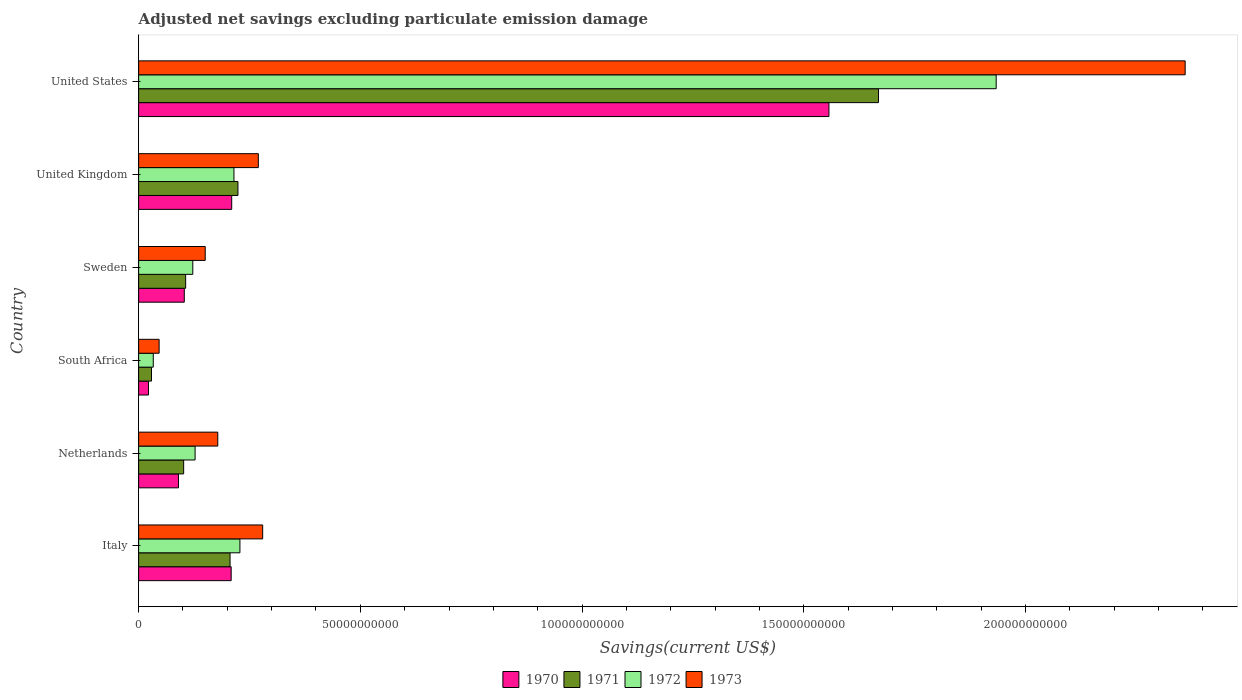How many different coloured bars are there?
Offer a very short reply. 4. How many groups of bars are there?
Your answer should be compact. 6. Are the number of bars on each tick of the Y-axis equal?
Ensure brevity in your answer.  Yes. How many bars are there on the 2nd tick from the bottom?
Offer a terse response. 4. In how many cases, is the number of bars for a given country not equal to the number of legend labels?
Offer a terse response. 0. What is the adjusted net savings in 1972 in Netherlands?
Keep it short and to the point. 1.27e+1. Across all countries, what is the maximum adjusted net savings in 1972?
Your response must be concise. 1.93e+11. Across all countries, what is the minimum adjusted net savings in 1973?
Give a very brief answer. 4.62e+09. In which country was the adjusted net savings in 1973 minimum?
Provide a succinct answer. South Africa. What is the total adjusted net savings in 1971 in the graph?
Offer a very short reply. 2.34e+11. What is the difference between the adjusted net savings in 1972 in Italy and that in Netherlands?
Keep it short and to the point. 1.01e+1. What is the difference between the adjusted net savings in 1973 in United Kingdom and the adjusted net savings in 1972 in Netherlands?
Give a very brief answer. 1.43e+1. What is the average adjusted net savings in 1971 per country?
Offer a terse response. 3.89e+1. What is the difference between the adjusted net savings in 1971 and adjusted net savings in 1973 in South Africa?
Provide a succinct answer. -1.72e+09. What is the ratio of the adjusted net savings in 1970 in Sweden to that in United Kingdom?
Keep it short and to the point. 0.49. What is the difference between the highest and the second highest adjusted net savings in 1972?
Provide a succinct answer. 1.71e+11. What is the difference between the highest and the lowest adjusted net savings in 1970?
Offer a terse response. 1.53e+11. In how many countries, is the adjusted net savings in 1971 greater than the average adjusted net savings in 1971 taken over all countries?
Your answer should be very brief. 1. Is the sum of the adjusted net savings in 1973 in South Africa and United Kingdom greater than the maximum adjusted net savings in 1970 across all countries?
Make the answer very short. No. How many countries are there in the graph?
Provide a succinct answer. 6. What is the difference between two consecutive major ticks on the X-axis?
Ensure brevity in your answer.  5.00e+1. Does the graph contain any zero values?
Provide a succinct answer. No. Where does the legend appear in the graph?
Your answer should be very brief. Bottom center. How many legend labels are there?
Offer a very short reply. 4. How are the legend labels stacked?
Keep it short and to the point. Horizontal. What is the title of the graph?
Offer a terse response. Adjusted net savings excluding particulate emission damage. What is the label or title of the X-axis?
Your answer should be very brief. Savings(current US$). What is the Savings(current US$) of 1970 in Italy?
Offer a very short reply. 2.09e+1. What is the Savings(current US$) in 1971 in Italy?
Give a very brief answer. 2.06e+1. What is the Savings(current US$) in 1972 in Italy?
Your response must be concise. 2.28e+1. What is the Savings(current US$) of 1973 in Italy?
Give a very brief answer. 2.80e+1. What is the Savings(current US$) of 1970 in Netherlands?
Offer a terse response. 8.99e+09. What is the Savings(current US$) of 1971 in Netherlands?
Offer a terse response. 1.02e+1. What is the Savings(current US$) in 1972 in Netherlands?
Provide a short and direct response. 1.27e+1. What is the Savings(current US$) of 1973 in Netherlands?
Your answer should be compact. 1.79e+1. What is the Savings(current US$) in 1970 in South Africa?
Provide a succinct answer. 2.22e+09. What is the Savings(current US$) of 1971 in South Africa?
Your answer should be compact. 2.90e+09. What is the Savings(current US$) of 1972 in South Africa?
Make the answer very short. 3.30e+09. What is the Savings(current US$) of 1973 in South Africa?
Your answer should be compact. 4.62e+09. What is the Savings(current US$) in 1970 in Sweden?
Offer a very short reply. 1.03e+1. What is the Savings(current US$) in 1971 in Sweden?
Ensure brevity in your answer.  1.06e+1. What is the Savings(current US$) in 1972 in Sweden?
Give a very brief answer. 1.22e+1. What is the Savings(current US$) in 1973 in Sweden?
Your response must be concise. 1.50e+1. What is the Savings(current US$) of 1970 in United Kingdom?
Make the answer very short. 2.10e+1. What is the Savings(current US$) in 1971 in United Kingdom?
Offer a terse response. 2.24e+1. What is the Savings(current US$) of 1972 in United Kingdom?
Your response must be concise. 2.15e+1. What is the Savings(current US$) in 1973 in United Kingdom?
Give a very brief answer. 2.70e+1. What is the Savings(current US$) in 1970 in United States?
Your response must be concise. 1.56e+11. What is the Savings(current US$) of 1971 in United States?
Keep it short and to the point. 1.67e+11. What is the Savings(current US$) in 1972 in United States?
Provide a short and direct response. 1.93e+11. What is the Savings(current US$) of 1973 in United States?
Offer a terse response. 2.36e+11. Across all countries, what is the maximum Savings(current US$) of 1970?
Make the answer very short. 1.56e+11. Across all countries, what is the maximum Savings(current US$) of 1971?
Your response must be concise. 1.67e+11. Across all countries, what is the maximum Savings(current US$) in 1972?
Give a very brief answer. 1.93e+11. Across all countries, what is the maximum Savings(current US$) in 1973?
Give a very brief answer. 2.36e+11. Across all countries, what is the minimum Savings(current US$) in 1970?
Provide a short and direct response. 2.22e+09. Across all countries, what is the minimum Savings(current US$) in 1971?
Keep it short and to the point. 2.90e+09. Across all countries, what is the minimum Savings(current US$) in 1972?
Your answer should be compact. 3.30e+09. Across all countries, what is the minimum Savings(current US$) of 1973?
Offer a terse response. 4.62e+09. What is the total Savings(current US$) of 1970 in the graph?
Provide a short and direct response. 2.19e+11. What is the total Savings(current US$) in 1971 in the graph?
Ensure brevity in your answer.  2.34e+11. What is the total Savings(current US$) in 1972 in the graph?
Provide a short and direct response. 2.66e+11. What is the total Savings(current US$) in 1973 in the graph?
Your response must be concise. 3.28e+11. What is the difference between the Savings(current US$) in 1970 in Italy and that in Netherlands?
Make the answer very short. 1.19e+1. What is the difference between the Savings(current US$) of 1971 in Italy and that in Netherlands?
Your answer should be very brief. 1.05e+1. What is the difference between the Savings(current US$) in 1972 in Italy and that in Netherlands?
Give a very brief answer. 1.01e+1. What is the difference between the Savings(current US$) in 1973 in Italy and that in Netherlands?
Your answer should be compact. 1.01e+1. What is the difference between the Savings(current US$) in 1970 in Italy and that in South Africa?
Provide a succinct answer. 1.87e+1. What is the difference between the Savings(current US$) of 1971 in Italy and that in South Africa?
Your response must be concise. 1.77e+1. What is the difference between the Savings(current US$) in 1972 in Italy and that in South Africa?
Your response must be concise. 1.95e+1. What is the difference between the Savings(current US$) of 1973 in Italy and that in South Africa?
Your answer should be compact. 2.34e+1. What is the difference between the Savings(current US$) in 1970 in Italy and that in Sweden?
Your answer should be compact. 1.06e+1. What is the difference between the Savings(current US$) of 1971 in Italy and that in Sweden?
Provide a succinct answer. 1.00e+1. What is the difference between the Savings(current US$) in 1972 in Italy and that in Sweden?
Your answer should be very brief. 1.06e+1. What is the difference between the Savings(current US$) in 1973 in Italy and that in Sweden?
Offer a terse response. 1.30e+1. What is the difference between the Savings(current US$) in 1970 in Italy and that in United Kingdom?
Make the answer very short. -1.20e+08. What is the difference between the Savings(current US$) of 1971 in Italy and that in United Kingdom?
Provide a succinct answer. -1.78e+09. What is the difference between the Savings(current US$) of 1972 in Italy and that in United Kingdom?
Provide a short and direct response. 1.34e+09. What is the difference between the Savings(current US$) of 1973 in Italy and that in United Kingdom?
Give a very brief answer. 9.78e+08. What is the difference between the Savings(current US$) of 1970 in Italy and that in United States?
Your response must be concise. -1.35e+11. What is the difference between the Savings(current US$) of 1971 in Italy and that in United States?
Offer a terse response. -1.46e+11. What is the difference between the Savings(current US$) of 1972 in Italy and that in United States?
Provide a succinct answer. -1.71e+11. What is the difference between the Savings(current US$) in 1973 in Italy and that in United States?
Give a very brief answer. -2.08e+11. What is the difference between the Savings(current US$) in 1970 in Netherlands and that in South Africa?
Offer a very short reply. 6.77e+09. What is the difference between the Savings(current US$) in 1971 in Netherlands and that in South Africa?
Give a very brief answer. 7.25e+09. What is the difference between the Savings(current US$) of 1972 in Netherlands and that in South Africa?
Provide a short and direct response. 9.43e+09. What is the difference between the Savings(current US$) of 1973 in Netherlands and that in South Africa?
Offer a very short reply. 1.32e+1. What is the difference between the Savings(current US$) in 1970 in Netherlands and that in Sweden?
Your answer should be very brief. -1.31e+09. What is the difference between the Savings(current US$) in 1971 in Netherlands and that in Sweden?
Give a very brief answer. -4.54e+08. What is the difference between the Savings(current US$) in 1972 in Netherlands and that in Sweden?
Your answer should be very brief. 5.20e+08. What is the difference between the Savings(current US$) of 1973 in Netherlands and that in Sweden?
Make the answer very short. 2.83e+09. What is the difference between the Savings(current US$) of 1970 in Netherlands and that in United Kingdom?
Your response must be concise. -1.20e+1. What is the difference between the Savings(current US$) of 1971 in Netherlands and that in United Kingdom?
Your answer should be very brief. -1.22e+1. What is the difference between the Savings(current US$) of 1972 in Netherlands and that in United Kingdom?
Provide a short and direct response. -8.76e+09. What is the difference between the Savings(current US$) of 1973 in Netherlands and that in United Kingdom?
Make the answer very short. -9.15e+09. What is the difference between the Savings(current US$) in 1970 in Netherlands and that in United States?
Ensure brevity in your answer.  -1.47e+11. What is the difference between the Savings(current US$) of 1971 in Netherlands and that in United States?
Keep it short and to the point. -1.57e+11. What is the difference between the Savings(current US$) of 1972 in Netherlands and that in United States?
Your response must be concise. -1.81e+11. What is the difference between the Savings(current US$) in 1973 in Netherlands and that in United States?
Make the answer very short. -2.18e+11. What is the difference between the Savings(current US$) in 1970 in South Africa and that in Sweden?
Provide a short and direct response. -8.08e+09. What is the difference between the Savings(current US$) in 1971 in South Africa and that in Sweden?
Your answer should be compact. -7.70e+09. What is the difference between the Savings(current US$) in 1972 in South Africa and that in Sweden?
Offer a terse response. -8.91e+09. What is the difference between the Savings(current US$) in 1973 in South Africa and that in Sweden?
Provide a short and direct response. -1.04e+1. What is the difference between the Savings(current US$) of 1970 in South Africa and that in United Kingdom?
Provide a succinct answer. -1.88e+1. What is the difference between the Savings(current US$) of 1971 in South Africa and that in United Kingdom?
Ensure brevity in your answer.  -1.95e+1. What is the difference between the Savings(current US$) of 1972 in South Africa and that in United Kingdom?
Your response must be concise. -1.82e+1. What is the difference between the Savings(current US$) in 1973 in South Africa and that in United Kingdom?
Provide a short and direct response. -2.24e+1. What is the difference between the Savings(current US$) in 1970 in South Africa and that in United States?
Give a very brief answer. -1.53e+11. What is the difference between the Savings(current US$) in 1971 in South Africa and that in United States?
Offer a terse response. -1.64e+11. What is the difference between the Savings(current US$) in 1972 in South Africa and that in United States?
Keep it short and to the point. -1.90e+11. What is the difference between the Savings(current US$) of 1973 in South Africa and that in United States?
Ensure brevity in your answer.  -2.31e+11. What is the difference between the Savings(current US$) of 1970 in Sweden and that in United Kingdom?
Make the answer very short. -1.07e+1. What is the difference between the Savings(current US$) in 1971 in Sweden and that in United Kingdom?
Keep it short and to the point. -1.18e+1. What is the difference between the Savings(current US$) of 1972 in Sweden and that in United Kingdom?
Ensure brevity in your answer.  -9.28e+09. What is the difference between the Savings(current US$) of 1973 in Sweden and that in United Kingdom?
Give a very brief answer. -1.20e+1. What is the difference between the Savings(current US$) in 1970 in Sweden and that in United States?
Your answer should be very brief. -1.45e+11. What is the difference between the Savings(current US$) in 1971 in Sweden and that in United States?
Give a very brief answer. -1.56e+11. What is the difference between the Savings(current US$) of 1972 in Sweden and that in United States?
Give a very brief answer. -1.81e+11. What is the difference between the Savings(current US$) of 1973 in Sweden and that in United States?
Your answer should be compact. -2.21e+11. What is the difference between the Savings(current US$) in 1970 in United Kingdom and that in United States?
Give a very brief answer. -1.35e+11. What is the difference between the Savings(current US$) of 1971 in United Kingdom and that in United States?
Make the answer very short. -1.44e+11. What is the difference between the Savings(current US$) of 1972 in United Kingdom and that in United States?
Your answer should be compact. -1.72e+11. What is the difference between the Savings(current US$) of 1973 in United Kingdom and that in United States?
Make the answer very short. -2.09e+11. What is the difference between the Savings(current US$) of 1970 in Italy and the Savings(current US$) of 1971 in Netherlands?
Your answer should be compact. 1.07e+1. What is the difference between the Savings(current US$) in 1970 in Italy and the Savings(current US$) in 1972 in Netherlands?
Give a very brief answer. 8.14e+09. What is the difference between the Savings(current US$) of 1970 in Italy and the Savings(current US$) of 1973 in Netherlands?
Offer a very short reply. 3.02e+09. What is the difference between the Savings(current US$) in 1971 in Italy and the Savings(current US$) in 1972 in Netherlands?
Provide a short and direct response. 7.88e+09. What is the difference between the Savings(current US$) of 1971 in Italy and the Savings(current US$) of 1973 in Netherlands?
Keep it short and to the point. 2.77e+09. What is the difference between the Savings(current US$) of 1972 in Italy and the Savings(current US$) of 1973 in Netherlands?
Your response must be concise. 4.99e+09. What is the difference between the Savings(current US$) of 1970 in Italy and the Savings(current US$) of 1971 in South Africa?
Offer a very short reply. 1.80e+1. What is the difference between the Savings(current US$) in 1970 in Italy and the Savings(current US$) in 1972 in South Africa?
Your response must be concise. 1.76e+1. What is the difference between the Savings(current US$) in 1970 in Italy and the Savings(current US$) in 1973 in South Africa?
Provide a succinct answer. 1.62e+1. What is the difference between the Savings(current US$) of 1971 in Italy and the Savings(current US$) of 1972 in South Africa?
Make the answer very short. 1.73e+1. What is the difference between the Savings(current US$) in 1971 in Italy and the Savings(current US$) in 1973 in South Africa?
Your answer should be compact. 1.60e+1. What is the difference between the Savings(current US$) of 1972 in Italy and the Savings(current US$) of 1973 in South Africa?
Your answer should be very brief. 1.82e+1. What is the difference between the Savings(current US$) of 1970 in Italy and the Savings(current US$) of 1971 in Sweden?
Your answer should be very brief. 1.03e+1. What is the difference between the Savings(current US$) of 1970 in Italy and the Savings(current US$) of 1972 in Sweden?
Offer a very short reply. 8.66e+09. What is the difference between the Savings(current US$) of 1970 in Italy and the Savings(current US$) of 1973 in Sweden?
Keep it short and to the point. 5.85e+09. What is the difference between the Savings(current US$) in 1971 in Italy and the Savings(current US$) in 1972 in Sweden?
Make the answer very short. 8.40e+09. What is the difference between the Savings(current US$) of 1971 in Italy and the Savings(current US$) of 1973 in Sweden?
Provide a short and direct response. 5.60e+09. What is the difference between the Savings(current US$) of 1972 in Italy and the Savings(current US$) of 1973 in Sweden?
Offer a terse response. 7.83e+09. What is the difference between the Savings(current US$) in 1970 in Italy and the Savings(current US$) in 1971 in United Kingdom?
Ensure brevity in your answer.  -1.53e+09. What is the difference between the Savings(current US$) in 1970 in Italy and the Savings(current US$) in 1972 in United Kingdom?
Provide a short and direct response. -6.28e+08. What is the difference between the Savings(current US$) in 1970 in Italy and the Savings(current US$) in 1973 in United Kingdom?
Offer a terse response. -6.13e+09. What is the difference between the Savings(current US$) of 1971 in Italy and the Savings(current US$) of 1972 in United Kingdom?
Provide a short and direct response. -8.80e+08. What is the difference between the Savings(current US$) in 1971 in Italy and the Savings(current US$) in 1973 in United Kingdom?
Give a very brief answer. -6.38e+09. What is the difference between the Savings(current US$) of 1972 in Italy and the Savings(current US$) of 1973 in United Kingdom?
Your answer should be very brief. -4.15e+09. What is the difference between the Savings(current US$) of 1970 in Italy and the Savings(current US$) of 1971 in United States?
Your answer should be very brief. -1.46e+11. What is the difference between the Savings(current US$) in 1970 in Italy and the Savings(current US$) in 1972 in United States?
Your answer should be compact. -1.73e+11. What is the difference between the Savings(current US$) in 1970 in Italy and the Savings(current US$) in 1973 in United States?
Your answer should be very brief. -2.15e+11. What is the difference between the Savings(current US$) of 1971 in Italy and the Savings(current US$) of 1972 in United States?
Make the answer very short. -1.73e+11. What is the difference between the Savings(current US$) in 1971 in Italy and the Savings(current US$) in 1973 in United States?
Offer a terse response. -2.15e+11. What is the difference between the Savings(current US$) in 1972 in Italy and the Savings(current US$) in 1973 in United States?
Your answer should be compact. -2.13e+11. What is the difference between the Savings(current US$) of 1970 in Netherlands and the Savings(current US$) of 1971 in South Africa?
Offer a terse response. 6.09e+09. What is the difference between the Savings(current US$) of 1970 in Netherlands and the Savings(current US$) of 1972 in South Africa?
Ensure brevity in your answer.  5.69e+09. What is the difference between the Savings(current US$) in 1970 in Netherlands and the Savings(current US$) in 1973 in South Africa?
Ensure brevity in your answer.  4.37e+09. What is the difference between the Savings(current US$) in 1971 in Netherlands and the Savings(current US$) in 1972 in South Africa?
Ensure brevity in your answer.  6.85e+09. What is the difference between the Savings(current US$) of 1971 in Netherlands and the Savings(current US$) of 1973 in South Africa?
Your answer should be compact. 5.53e+09. What is the difference between the Savings(current US$) of 1972 in Netherlands and the Savings(current US$) of 1973 in South Africa?
Give a very brief answer. 8.11e+09. What is the difference between the Savings(current US$) of 1970 in Netherlands and the Savings(current US$) of 1971 in Sweden?
Provide a short and direct response. -1.62e+09. What is the difference between the Savings(current US$) in 1970 in Netherlands and the Savings(current US$) in 1972 in Sweden?
Keep it short and to the point. -3.23e+09. What is the difference between the Savings(current US$) of 1970 in Netherlands and the Savings(current US$) of 1973 in Sweden?
Keep it short and to the point. -6.03e+09. What is the difference between the Savings(current US$) in 1971 in Netherlands and the Savings(current US$) in 1972 in Sweden?
Make the answer very short. -2.06e+09. What is the difference between the Savings(current US$) of 1971 in Netherlands and the Savings(current US$) of 1973 in Sweden?
Your answer should be very brief. -4.86e+09. What is the difference between the Savings(current US$) in 1972 in Netherlands and the Savings(current US$) in 1973 in Sweden?
Ensure brevity in your answer.  -2.28e+09. What is the difference between the Savings(current US$) in 1970 in Netherlands and the Savings(current US$) in 1971 in United Kingdom?
Provide a succinct answer. -1.34e+1. What is the difference between the Savings(current US$) of 1970 in Netherlands and the Savings(current US$) of 1972 in United Kingdom?
Offer a very short reply. -1.25e+1. What is the difference between the Savings(current US$) of 1970 in Netherlands and the Savings(current US$) of 1973 in United Kingdom?
Provide a short and direct response. -1.80e+1. What is the difference between the Savings(current US$) of 1971 in Netherlands and the Savings(current US$) of 1972 in United Kingdom?
Offer a very short reply. -1.13e+1. What is the difference between the Savings(current US$) in 1971 in Netherlands and the Savings(current US$) in 1973 in United Kingdom?
Your response must be concise. -1.68e+1. What is the difference between the Savings(current US$) in 1972 in Netherlands and the Savings(current US$) in 1973 in United Kingdom?
Keep it short and to the point. -1.43e+1. What is the difference between the Savings(current US$) in 1970 in Netherlands and the Savings(current US$) in 1971 in United States?
Your answer should be compact. -1.58e+11. What is the difference between the Savings(current US$) in 1970 in Netherlands and the Savings(current US$) in 1972 in United States?
Give a very brief answer. -1.84e+11. What is the difference between the Savings(current US$) of 1970 in Netherlands and the Savings(current US$) of 1973 in United States?
Provide a succinct answer. -2.27e+11. What is the difference between the Savings(current US$) of 1971 in Netherlands and the Savings(current US$) of 1972 in United States?
Give a very brief answer. -1.83e+11. What is the difference between the Savings(current US$) of 1971 in Netherlands and the Savings(current US$) of 1973 in United States?
Your answer should be compact. -2.26e+11. What is the difference between the Savings(current US$) of 1972 in Netherlands and the Savings(current US$) of 1973 in United States?
Provide a short and direct response. -2.23e+11. What is the difference between the Savings(current US$) of 1970 in South Africa and the Savings(current US$) of 1971 in Sweden?
Your answer should be compact. -8.39e+09. What is the difference between the Savings(current US$) of 1970 in South Africa and the Savings(current US$) of 1972 in Sweden?
Make the answer very short. -1.00e+1. What is the difference between the Savings(current US$) in 1970 in South Africa and the Savings(current US$) in 1973 in Sweden?
Provide a succinct answer. -1.28e+1. What is the difference between the Savings(current US$) of 1971 in South Africa and the Savings(current US$) of 1972 in Sweden?
Keep it short and to the point. -9.31e+09. What is the difference between the Savings(current US$) of 1971 in South Africa and the Savings(current US$) of 1973 in Sweden?
Offer a very short reply. -1.21e+1. What is the difference between the Savings(current US$) in 1972 in South Africa and the Savings(current US$) in 1973 in Sweden?
Your response must be concise. -1.17e+1. What is the difference between the Savings(current US$) of 1970 in South Africa and the Savings(current US$) of 1971 in United Kingdom?
Provide a short and direct response. -2.02e+1. What is the difference between the Savings(current US$) in 1970 in South Africa and the Savings(current US$) in 1972 in United Kingdom?
Give a very brief answer. -1.93e+1. What is the difference between the Savings(current US$) in 1970 in South Africa and the Savings(current US$) in 1973 in United Kingdom?
Provide a succinct answer. -2.48e+1. What is the difference between the Savings(current US$) of 1971 in South Africa and the Savings(current US$) of 1972 in United Kingdom?
Offer a very short reply. -1.86e+1. What is the difference between the Savings(current US$) in 1971 in South Africa and the Savings(current US$) in 1973 in United Kingdom?
Your answer should be very brief. -2.41e+1. What is the difference between the Savings(current US$) of 1972 in South Africa and the Savings(current US$) of 1973 in United Kingdom?
Provide a short and direct response. -2.37e+1. What is the difference between the Savings(current US$) in 1970 in South Africa and the Savings(current US$) in 1971 in United States?
Ensure brevity in your answer.  -1.65e+11. What is the difference between the Savings(current US$) in 1970 in South Africa and the Savings(current US$) in 1972 in United States?
Your answer should be very brief. -1.91e+11. What is the difference between the Savings(current US$) in 1970 in South Africa and the Savings(current US$) in 1973 in United States?
Your answer should be compact. -2.34e+11. What is the difference between the Savings(current US$) of 1971 in South Africa and the Savings(current US$) of 1972 in United States?
Your response must be concise. -1.91e+11. What is the difference between the Savings(current US$) in 1971 in South Africa and the Savings(current US$) in 1973 in United States?
Offer a terse response. -2.33e+11. What is the difference between the Savings(current US$) in 1972 in South Africa and the Savings(current US$) in 1973 in United States?
Offer a terse response. -2.33e+11. What is the difference between the Savings(current US$) of 1970 in Sweden and the Savings(current US$) of 1971 in United Kingdom?
Keep it short and to the point. -1.21e+1. What is the difference between the Savings(current US$) of 1970 in Sweden and the Savings(current US$) of 1972 in United Kingdom?
Your response must be concise. -1.12e+1. What is the difference between the Savings(current US$) of 1970 in Sweden and the Savings(current US$) of 1973 in United Kingdom?
Provide a succinct answer. -1.67e+1. What is the difference between the Savings(current US$) of 1971 in Sweden and the Savings(current US$) of 1972 in United Kingdom?
Give a very brief answer. -1.09e+1. What is the difference between the Savings(current US$) in 1971 in Sweden and the Savings(current US$) in 1973 in United Kingdom?
Give a very brief answer. -1.64e+1. What is the difference between the Savings(current US$) in 1972 in Sweden and the Savings(current US$) in 1973 in United Kingdom?
Offer a very short reply. -1.48e+1. What is the difference between the Savings(current US$) in 1970 in Sweden and the Savings(current US$) in 1971 in United States?
Offer a terse response. -1.57e+11. What is the difference between the Savings(current US$) in 1970 in Sweden and the Savings(current US$) in 1972 in United States?
Provide a short and direct response. -1.83e+11. What is the difference between the Savings(current US$) in 1970 in Sweden and the Savings(current US$) in 1973 in United States?
Ensure brevity in your answer.  -2.26e+11. What is the difference between the Savings(current US$) in 1971 in Sweden and the Savings(current US$) in 1972 in United States?
Give a very brief answer. -1.83e+11. What is the difference between the Savings(current US$) of 1971 in Sweden and the Savings(current US$) of 1973 in United States?
Your answer should be very brief. -2.25e+11. What is the difference between the Savings(current US$) of 1972 in Sweden and the Savings(current US$) of 1973 in United States?
Your answer should be very brief. -2.24e+11. What is the difference between the Savings(current US$) of 1970 in United Kingdom and the Savings(current US$) of 1971 in United States?
Give a very brief answer. -1.46e+11. What is the difference between the Savings(current US$) of 1970 in United Kingdom and the Savings(current US$) of 1972 in United States?
Keep it short and to the point. -1.72e+11. What is the difference between the Savings(current US$) of 1970 in United Kingdom and the Savings(current US$) of 1973 in United States?
Offer a very short reply. -2.15e+11. What is the difference between the Savings(current US$) in 1971 in United Kingdom and the Savings(current US$) in 1972 in United States?
Offer a terse response. -1.71e+11. What is the difference between the Savings(current US$) of 1971 in United Kingdom and the Savings(current US$) of 1973 in United States?
Your answer should be compact. -2.14e+11. What is the difference between the Savings(current US$) in 1972 in United Kingdom and the Savings(current US$) in 1973 in United States?
Ensure brevity in your answer.  -2.15e+11. What is the average Savings(current US$) of 1970 per country?
Keep it short and to the point. 3.65e+1. What is the average Savings(current US$) of 1971 per country?
Your response must be concise. 3.89e+1. What is the average Savings(current US$) of 1972 per country?
Offer a terse response. 4.43e+1. What is the average Savings(current US$) in 1973 per country?
Give a very brief answer. 5.47e+1. What is the difference between the Savings(current US$) of 1970 and Savings(current US$) of 1971 in Italy?
Keep it short and to the point. 2.53e+08. What is the difference between the Savings(current US$) in 1970 and Savings(current US$) in 1972 in Italy?
Provide a succinct answer. -1.97e+09. What is the difference between the Savings(current US$) of 1970 and Savings(current US$) of 1973 in Italy?
Keep it short and to the point. -7.11e+09. What is the difference between the Savings(current US$) in 1971 and Savings(current US$) in 1972 in Italy?
Make the answer very short. -2.23e+09. What is the difference between the Savings(current US$) in 1971 and Savings(current US$) in 1973 in Italy?
Keep it short and to the point. -7.36e+09. What is the difference between the Savings(current US$) of 1972 and Savings(current US$) of 1973 in Italy?
Your answer should be compact. -5.13e+09. What is the difference between the Savings(current US$) in 1970 and Savings(current US$) in 1971 in Netherlands?
Offer a terse response. -1.17e+09. What is the difference between the Savings(current US$) of 1970 and Savings(current US$) of 1972 in Netherlands?
Give a very brief answer. -3.75e+09. What is the difference between the Savings(current US$) in 1970 and Savings(current US$) in 1973 in Netherlands?
Provide a short and direct response. -8.86e+09. What is the difference between the Savings(current US$) of 1971 and Savings(current US$) of 1972 in Netherlands?
Keep it short and to the point. -2.58e+09. What is the difference between the Savings(current US$) in 1971 and Savings(current US$) in 1973 in Netherlands?
Give a very brief answer. -7.70e+09. What is the difference between the Savings(current US$) of 1972 and Savings(current US$) of 1973 in Netherlands?
Your response must be concise. -5.11e+09. What is the difference between the Savings(current US$) of 1970 and Savings(current US$) of 1971 in South Africa?
Make the answer very short. -6.85e+08. What is the difference between the Savings(current US$) of 1970 and Savings(current US$) of 1972 in South Africa?
Your answer should be very brief. -1.08e+09. What is the difference between the Savings(current US$) in 1970 and Savings(current US$) in 1973 in South Africa?
Offer a very short reply. -2.40e+09. What is the difference between the Savings(current US$) in 1971 and Savings(current US$) in 1972 in South Africa?
Ensure brevity in your answer.  -4.00e+08. What is the difference between the Savings(current US$) of 1971 and Savings(current US$) of 1973 in South Africa?
Give a very brief answer. -1.72e+09. What is the difference between the Savings(current US$) in 1972 and Savings(current US$) in 1973 in South Africa?
Offer a terse response. -1.32e+09. What is the difference between the Savings(current US$) in 1970 and Savings(current US$) in 1971 in Sweden?
Offer a very short reply. -3.10e+08. What is the difference between the Savings(current US$) of 1970 and Savings(current US$) of 1972 in Sweden?
Provide a succinct answer. -1.92e+09. What is the difference between the Savings(current US$) of 1970 and Savings(current US$) of 1973 in Sweden?
Offer a terse response. -4.72e+09. What is the difference between the Savings(current US$) of 1971 and Savings(current US$) of 1972 in Sweden?
Ensure brevity in your answer.  -1.61e+09. What is the difference between the Savings(current US$) of 1971 and Savings(current US$) of 1973 in Sweden?
Give a very brief answer. -4.41e+09. What is the difference between the Savings(current US$) in 1972 and Savings(current US$) in 1973 in Sweden?
Ensure brevity in your answer.  -2.80e+09. What is the difference between the Savings(current US$) in 1970 and Savings(current US$) in 1971 in United Kingdom?
Provide a succinct answer. -1.41e+09. What is the difference between the Savings(current US$) in 1970 and Savings(current US$) in 1972 in United Kingdom?
Your response must be concise. -5.08e+08. What is the difference between the Savings(current US$) in 1970 and Savings(current US$) in 1973 in United Kingdom?
Your answer should be very brief. -6.01e+09. What is the difference between the Savings(current US$) of 1971 and Savings(current US$) of 1972 in United Kingdom?
Provide a short and direct response. 9.03e+08. What is the difference between the Savings(current US$) of 1971 and Savings(current US$) of 1973 in United Kingdom?
Ensure brevity in your answer.  -4.60e+09. What is the difference between the Savings(current US$) in 1972 and Savings(current US$) in 1973 in United Kingdom?
Your response must be concise. -5.50e+09. What is the difference between the Savings(current US$) in 1970 and Savings(current US$) in 1971 in United States?
Provide a succinct answer. -1.12e+1. What is the difference between the Savings(current US$) in 1970 and Savings(current US$) in 1972 in United States?
Make the answer very short. -3.77e+1. What is the difference between the Savings(current US$) of 1970 and Savings(current US$) of 1973 in United States?
Ensure brevity in your answer.  -8.03e+1. What is the difference between the Savings(current US$) of 1971 and Savings(current US$) of 1972 in United States?
Make the answer very short. -2.65e+1. What is the difference between the Savings(current US$) in 1971 and Savings(current US$) in 1973 in United States?
Ensure brevity in your answer.  -6.92e+1. What is the difference between the Savings(current US$) of 1972 and Savings(current US$) of 1973 in United States?
Provide a short and direct response. -4.26e+1. What is the ratio of the Savings(current US$) of 1970 in Italy to that in Netherlands?
Your response must be concise. 2.32. What is the ratio of the Savings(current US$) in 1971 in Italy to that in Netherlands?
Keep it short and to the point. 2.03. What is the ratio of the Savings(current US$) in 1972 in Italy to that in Netherlands?
Offer a very short reply. 1.79. What is the ratio of the Savings(current US$) in 1973 in Italy to that in Netherlands?
Offer a terse response. 1.57. What is the ratio of the Savings(current US$) in 1970 in Italy to that in South Africa?
Your answer should be very brief. 9.41. What is the ratio of the Savings(current US$) of 1971 in Italy to that in South Africa?
Your answer should be compact. 7.1. What is the ratio of the Savings(current US$) of 1972 in Italy to that in South Africa?
Offer a very short reply. 6.92. What is the ratio of the Savings(current US$) in 1973 in Italy to that in South Africa?
Your answer should be very brief. 6.05. What is the ratio of the Savings(current US$) in 1970 in Italy to that in Sweden?
Your answer should be very brief. 2.03. What is the ratio of the Savings(current US$) of 1971 in Italy to that in Sweden?
Ensure brevity in your answer.  1.94. What is the ratio of the Savings(current US$) in 1972 in Italy to that in Sweden?
Keep it short and to the point. 1.87. What is the ratio of the Savings(current US$) of 1973 in Italy to that in Sweden?
Your answer should be very brief. 1.86. What is the ratio of the Savings(current US$) in 1970 in Italy to that in United Kingdom?
Provide a succinct answer. 0.99. What is the ratio of the Savings(current US$) in 1971 in Italy to that in United Kingdom?
Ensure brevity in your answer.  0.92. What is the ratio of the Savings(current US$) of 1972 in Italy to that in United Kingdom?
Keep it short and to the point. 1.06. What is the ratio of the Savings(current US$) of 1973 in Italy to that in United Kingdom?
Make the answer very short. 1.04. What is the ratio of the Savings(current US$) in 1970 in Italy to that in United States?
Your response must be concise. 0.13. What is the ratio of the Savings(current US$) of 1971 in Italy to that in United States?
Provide a succinct answer. 0.12. What is the ratio of the Savings(current US$) of 1972 in Italy to that in United States?
Offer a terse response. 0.12. What is the ratio of the Savings(current US$) in 1973 in Italy to that in United States?
Provide a succinct answer. 0.12. What is the ratio of the Savings(current US$) of 1970 in Netherlands to that in South Africa?
Ensure brevity in your answer.  4.05. What is the ratio of the Savings(current US$) of 1971 in Netherlands to that in South Africa?
Your answer should be compact. 3.5. What is the ratio of the Savings(current US$) in 1972 in Netherlands to that in South Africa?
Your response must be concise. 3.86. What is the ratio of the Savings(current US$) in 1973 in Netherlands to that in South Africa?
Your answer should be very brief. 3.86. What is the ratio of the Savings(current US$) in 1970 in Netherlands to that in Sweden?
Give a very brief answer. 0.87. What is the ratio of the Savings(current US$) of 1971 in Netherlands to that in Sweden?
Offer a terse response. 0.96. What is the ratio of the Savings(current US$) in 1972 in Netherlands to that in Sweden?
Offer a terse response. 1.04. What is the ratio of the Savings(current US$) in 1973 in Netherlands to that in Sweden?
Ensure brevity in your answer.  1.19. What is the ratio of the Savings(current US$) in 1970 in Netherlands to that in United Kingdom?
Offer a very short reply. 0.43. What is the ratio of the Savings(current US$) in 1971 in Netherlands to that in United Kingdom?
Offer a terse response. 0.45. What is the ratio of the Savings(current US$) of 1972 in Netherlands to that in United Kingdom?
Provide a short and direct response. 0.59. What is the ratio of the Savings(current US$) in 1973 in Netherlands to that in United Kingdom?
Provide a short and direct response. 0.66. What is the ratio of the Savings(current US$) in 1970 in Netherlands to that in United States?
Offer a terse response. 0.06. What is the ratio of the Savings(current US$) of 1971 in Netherlands to that in United States?
Give a very brief answer. 0.06. What is the ratio of the Savings(current US$) of 1972 in Netherlands to that in United States?
Your answer should be compact. 0.07. What is the ratio of the Savings(current US$) in 1973 in Netherlands to that in United States?
Your response must be concise. 0.08. What is the ratio of the Savings(current US$) of 1970 in South Africa to that in Sweden?
Your response must be concise. 0.22. What is the ratio of the Savings(current US$) of 1971 in South Africa to that in Sweden?
Keep it short and to the point. 0.27. What is the ratio of the Savings(current US$) in 1972 in South Africa to that in Sweden?
Provide a short and direct response. 0.27. What is the ratio of the Savings(current US$) in 1973 in South Africa to that in Sweden?
Provide a short and direct response. 0.31. What is the ratio of the Savings(current US$) in 1970 in South Africa to that in United Kingdom?
Make the answer very short. 0.11. What is the ratio of the Savings(current US$) of 1971 in South Africa to that in United Kingdom?
Make the answer very short. 0.13. What is the ratio of the Savings(current US$) in 1972 in South Africa to that in United Kingdom?
Offer a terse response. 0.15. What is the ratio of the Savings(current US$) of 1973 in South Africa to that in United Kingdom?
Your response must be concise. 0.17. What is the ratio of the Savings(current US$) of 1970 in South Africa to that in United States?
Provide a succinct answer. 0.01. What is the ratio of the Savings(current US$) in 1971 in South Africa to that in United States?
Provide a succinct answer. 0.02. What is the ratio of the Savings(current US$) of 1972 in South Africa to that in United States?
Your answer should be compact. 0.02. What is the ratio of the Savings(current US$) in 1973 in South Africa to that in United States?
Give a very brief answer. 0.02. What is the ratio of the Savings(current US$) of 1970 in Sweden to that in United Kingdom?
Give a very brief answer. 0.49. What is the ratio of the Savings(current US$) of 1971 in Sweden to that in United Kingdom?
Give a very brief answer. 0.47. What is the ratio of the Savings(current US$) in 1972 in Sweden to that in United Kingdom?
Your answer should be compact. 0.57. What is the ratio of the Savings(current US$) in 1973 in Sweden to that in United Kingdom?
Your answer should be very brief. 0.56. What is the ratio of the Savings(current US$) in 1970 in Sweden to that in United States?
Provide a short and direct response. 0.07. What is the ratio of the Savings(current US$) in 1971 in Sweden to that in United States?
Provide a short and direct response. 0.06. What is the ratio of the Savings(current US$) in 1972 in Sweden to that in United States?
Your answer should be very brief. 0.06. What is the ratio of the Savings(current US$) of 1973 in Sweden to that in United States?
Keep it short and to the point. 0.06. What is the ratio of the Savings(current US$) of 1970 in United Kingdom to that in United States?
Offer a very short reply. 0.13. What is the ratio of the Savings(current US$) in 1971 in United Kingdom to that in United States?
Give a very brief answer. 0.13. What is the ratio of the Savings(current US$) in 1972 in United Kingdom to that in United States?
Offer a very short reply. 0.11. What is the ratio of the Savings(current US$) in 1973 in United Kingdom to that in United States?
Make the answer very short. 0.11. What is the difference between the highest and the second highest Savings(current US$) of 1970?
Ensure brevity in your answer.  1.35e+11. What is the difference between the highest and the second highest Savings(current US$) of 1971?
Your answer should be very brief. 1.44e+11. What is the difference between the highest and the second highest Savings(current US$) of 1972?
Make the answer very short. 1.71e+11. What is the difference between the highest and the second highest Savings(current US$) of 1973?
Offer a very short reply. 2.08e+11. What is the difference between the highest and the lowest Savings(current US$) in 1970?
Offer a terse response. 1.53e+11. What is the difference between the highest and the lowest Savings(current US$) in 1971?
Give a very brief answer. 1.64e+11. What is the difference between the highest and the lowest Savings(current US$) of 1972?
Offer a very short reply. 1.90e+11. What is the difference between the highest and the lowest Savings(current US$) of 1973?
Your answer should be compact. 2.31e+11. 